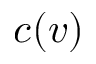<formula> <loc_0><loc_0><loc_500><loc_500>c ( v )</formula> 